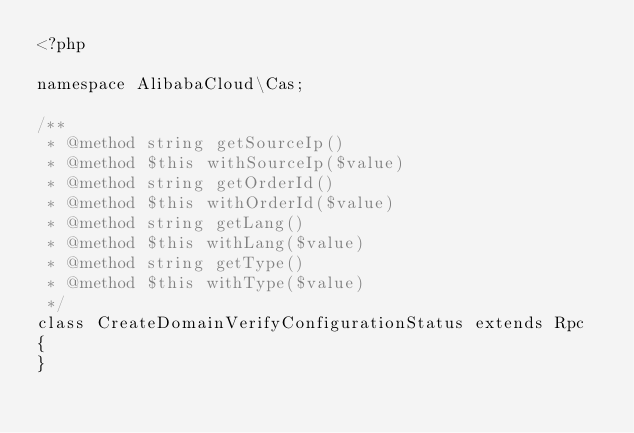<code> <loc_0><loc_0><loc_500><loc_500><_PHP_><?php

namespace AlibabaCloud\Cas;

/**
 * @method string getSourceIp()
 * @method $this withSourceIp($value)
 * @method string getOrderId()
 * @method $this withOrderId($value)
 * @method string getLang()
 * @method $this withLang($value)
 * @method string getType()
 * @method $this withType($value)
 */
class CreateDomainVerifyConfigurationStatus extends Rpc
{
}
</code> 